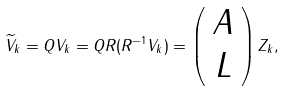Convert formula to latex. <formula><loc_0><loc_0><loc_500><loc_500>\widetilde { V } _ { k } = Q V _ { k } = Q R ( R ^ { - 1 } V _ { k } ) = \left ( \begin{array} { c } A \\ L \\ \end{array} \right ) Z _ { k } ,</formula> 